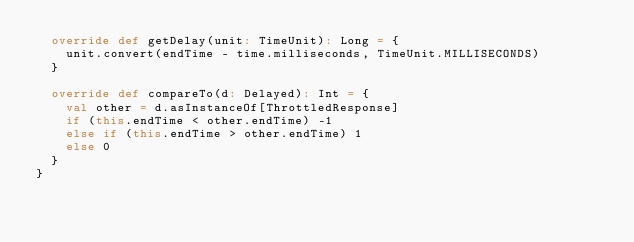Convert code to text. <code><loc_0><loc_0><loc_500><loc_500><_Scala_>  override def getDelay(unit: TimeUnit): Long = {
    unit.convert(endTime - time.milliseconds, TimeUnit.MILLISECONDS)
  }

  override def compareTo(d: Delayed): Int = {
    val other = d.asInstanceOf[ThrottledResponse]
    if (this.endTime < other.endTime) -1
    else if (this.endTime > other.endTime) 1
    else 0
  }
}
</code> 